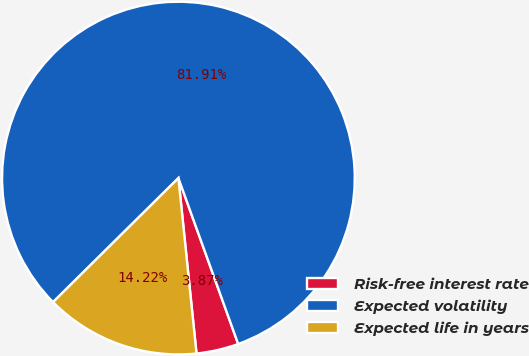<chart> <loc_0><loc_0><loc_500><loc_500><pie_chart><fcel>Risk-free interest rate<fcel>Expected volatility<fcel>Expected life in years<nl><fcel>3.87%<fcel>81.91%<fcel>14.22%<nl></chart> 